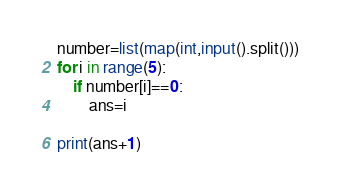<code> <loc_0><loc_0><loc_500><loc_500><_Python_>number=list(map(int,input().split()))
for i in range(5):
    if number[i]==0:
        ans=i

print(ans+1)</code> 